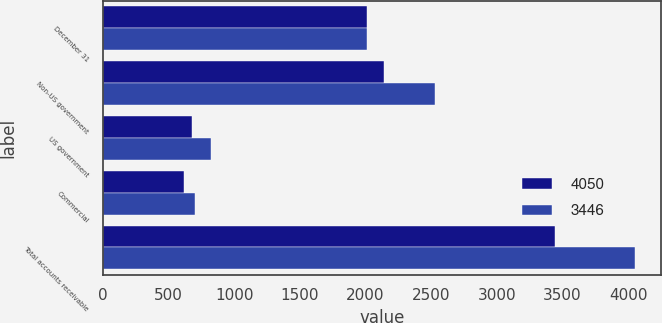Convert chart. <chart><loc_0><loc_0><loc_500><loc_500><stacked_bar_chart><ecel><fcel>December 31<fcel>Non-US government<fcel>US government<fcel>Commercial<fcel>Total accounts receivable<nl><fcel>4050<fcel>2015<fcel>2144<fcel>683<fcel>619<fcel>3446<nl><fcel>3446<fcel>2014<fcel>2529<fcel>822<fcel>699<fcel>4050<nl></chart> 